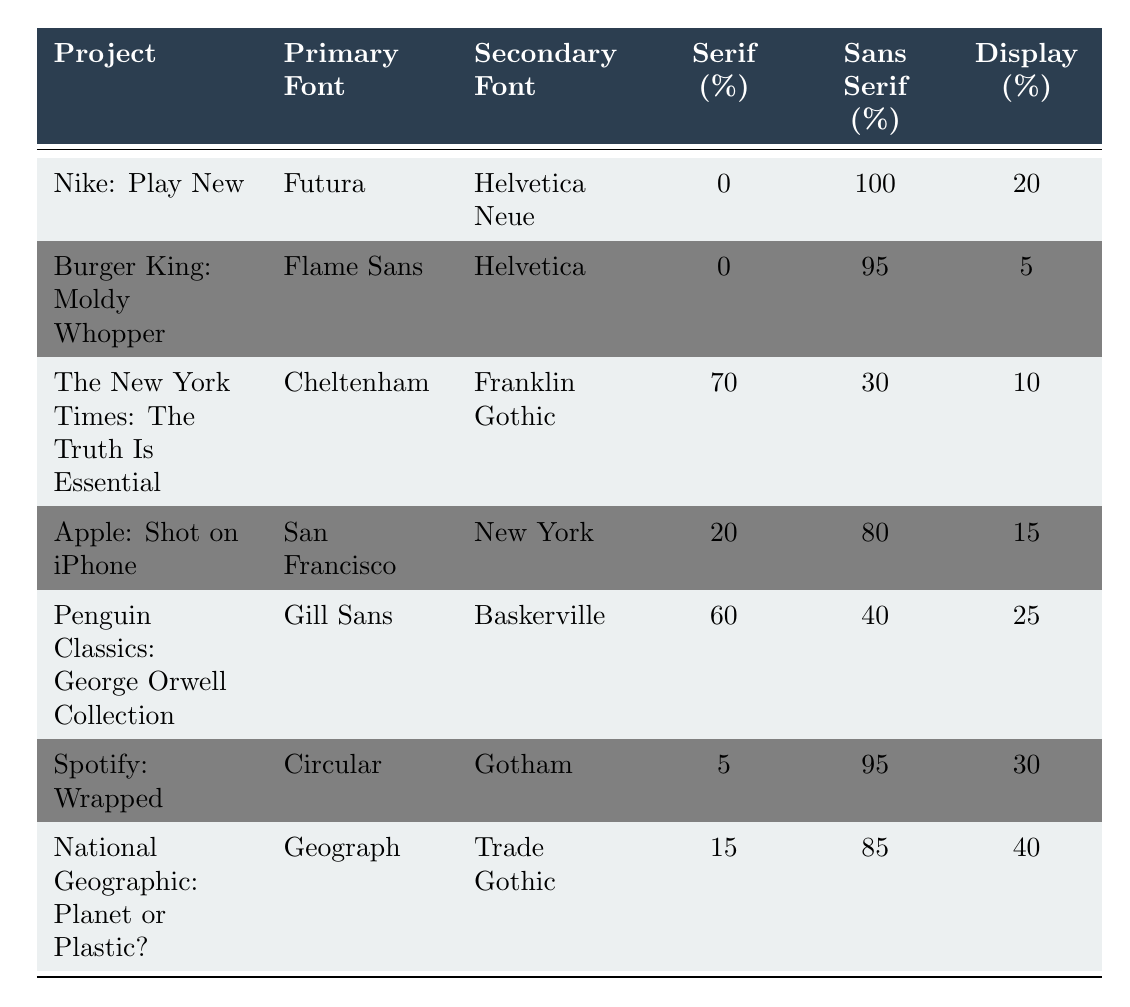What is the primary font used in the project "Nike: Play New"? The table shows that the primary font for the project "Nike: Play New" is listed under the "Primary Font" column, which is Futura.
Answer: Futura How many projects used a serif font as their primary font? By examining the "Serif (%)" column and identifying projects where this value is greater than 0, we find that both "The New York Times: The Truth Is Essential" and "Penguin Classics: George Orwell Collection" have serif usage. Therefore, there are 2 projects with a serif primary font.
Answer: 2 Which project has the highest display font usage? We compare the "Display (%)" column across all projects. The project "National Geographic: Planet or Plastic?" has the highest display font usage at 40%.
Answer: "National Geographic: Planet or Plastic?" Calculate the average sans serif usage across all projects. The sans serif usage percentages are: 100, 95, 30, 80, 40, 95, 85. Summing these: 100 + 95 + 30 + 80 + 40 + 95 + 85 = 525. There are 7 projects, so the average is 525 / 7 = 75.
Answer: 75 Is the project "Spotify: Wrapped" using a custom font? The "custom_font" column indicates whether a project has a custom font or not. For "Spotify: Wrapped," it is marked as true indicating that it used a custom font.
Answer: Yes What is the ratio of serif to sans serif usage for the project "Apple: Shot on iPhone"? For "Apple: Shot on iPhone," the serif usage is 20% and sans serif is 80%. The ratio is 20:80, which simplifies to 1:4.
Answer: 1:4 What percentage of the project "Burger King: Moldy Whopper" uses sans serif fonts? The "Burger King: Moldy Whopper" project shows 95% under the "Sans Serif (%)" column, directly indicating its usage.
Answer: 95% Which projects exhibited more than 20% usage of display fonts? The projects with display font usage greater than 20% are "Penguin Classics: George Orwell Collection" (25%) and "National Geographic: Planet or Plastic?" (40%). Thus, they both meet the criteria.
Answer: "Penguin Classics: George Orwell Collection" and "National Geographic: Planet or Plastic?" How does the serif font usage of "The New York Times: The Truth Is Essential" compare to "Nike: Play New"? "The New York Times: The Truth Is Essential" has 70% serif usage compared to "Nike: Play New," which has 0%. Thus, there is a significant difference.
Answer: 70% vs. 0% 